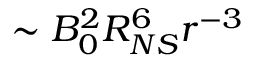<formula> <loc_0><loc_0><loc_500><loc_500>\sim B _ { 0 } ^ { 2 } R _ { N S } ^ { 6 } r ^ { - 3 }</formula> 